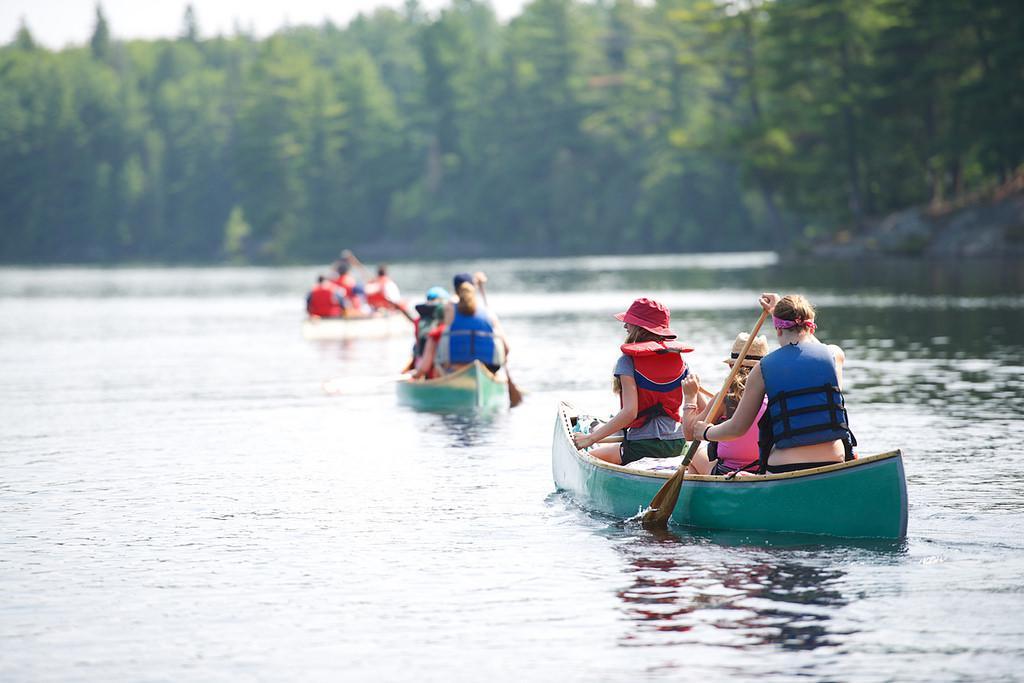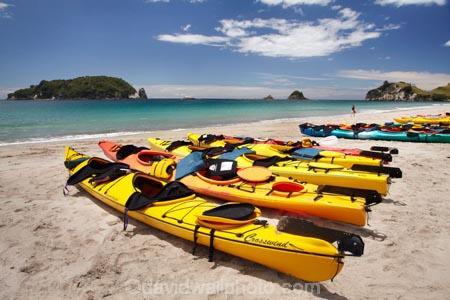The first image is the image on the left, the second image is the image on the right. Examine the images to the left and right. Is the description "rows of yellow canoes line the beach" accurate? Answer yes or no. Yes. The first image is the image on the left, the second image is the image on the right. For the images shown, is this caption "At least three yellow kayaks are arranged in a row in one of the images." true? Answer yes or no. Yes. 